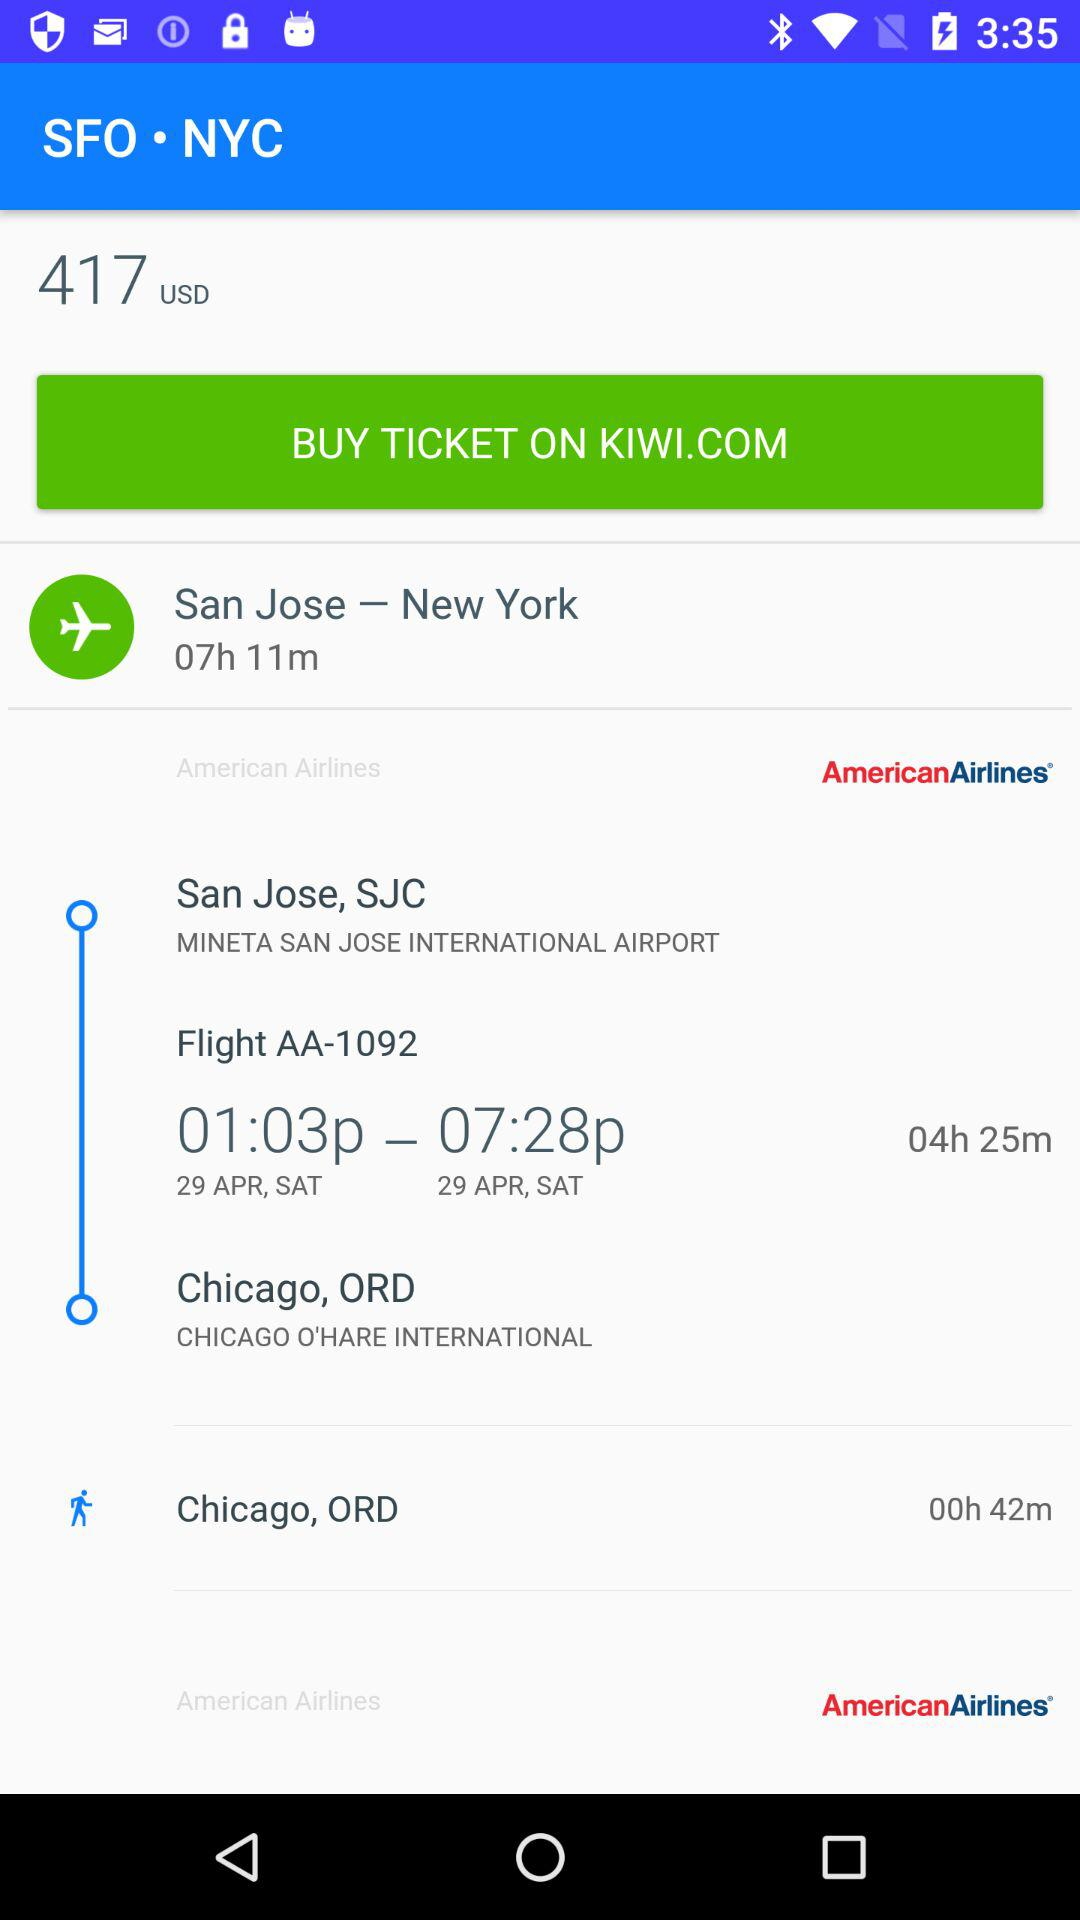What is the flight number? The flight number is AA-1092. 